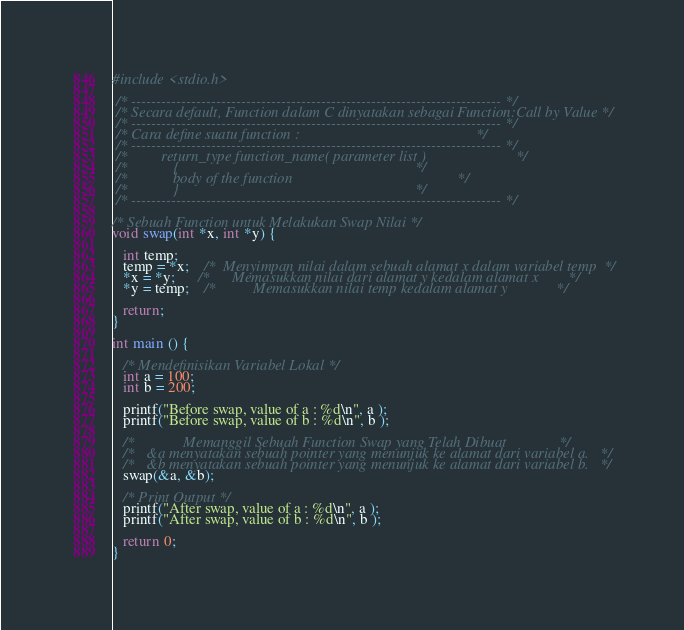<code> <loc_0><loc_0><loc_500><loc_500><_C_>#include <stdio.h>

 /* -------------------------------------------------------------------------- */
 /* Secara default, Function dalam C dinyatakan sebagai Function:Call by Value */
 /* -------------------------------------------------------------------------- */
 /* Cara define suatu function :                                               */
 /* -------------------------------------------------------------------------- */
 /*         return_type function_name( parameter list )                        */
 /*            {                                                               */ 
 /*            body of the function                                            */
 /*            }                                                               */
 /* -------------------------------------------------------------------------- */
 
/* Sebuah Function untuk Melakukan Swap Nilai */
void swap(int *x, int *y) {

   int temp;
   temp = *x;    /*  Menyimpan nilai dalam sebuah alamat x dalam variabel temp  */
   *x = *y;      /*      Memasukkan nilai dari alamat y kedalam alamat x        */
   *y = temp;    /*          Memasukkan nilai temp kedalam alamat y             */
  
   return;
}
 
int main () {

   /* Mendefinisikan Variabel Lokal */
   int a = 100;
   int b = 200;
 
   printf("Before swap, value of a : %d\n", a );
   printf("Before swap, value of b : %d\n", b );
 
   /*             Memanggil Sebuah Function Swap yang Telah Dibuat              */
   /*   &a menyatakan sebuah pointer yang menunjuk ke alamat dari variabel a.   */
   /*   &b menyatakan sebuah pointer yang menunjuk ke alamat dari variabel b.   */
   swap(&a, &b);
 
   /* Print Output */
   printf("After swap, value of a : %d\n", a );
   printf("After swap, value of b : %d\n", b );
 
   return 0;
}</code> 